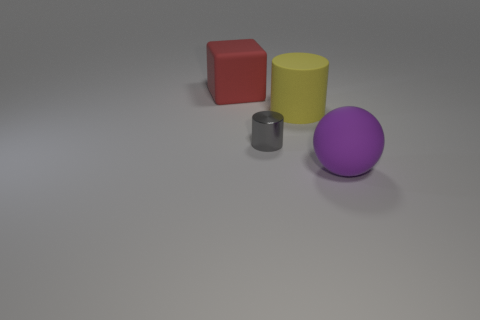Subtract all yellow cylinders. How many cylinders are left? 1 Add 3 tiny gray cylinders. How many objects exist? 7 Add 4 tiny gray things. How many tiny gray things exist? 5 Subtract 0 gray spheres. How many objects are left? 4 Subtract all cubes. How many objects are left? 3 Subtract all brown balls. Subtract all red cylinders. How many balls are left? 1 Subtract all blue cylinders. How many green cubes are left? 0 Subtract all purple shiny blocks. Subtract all yellow rubber things. How many objects are left? 3 Add 1 big cylinders. How many big cylinders are left? 2 